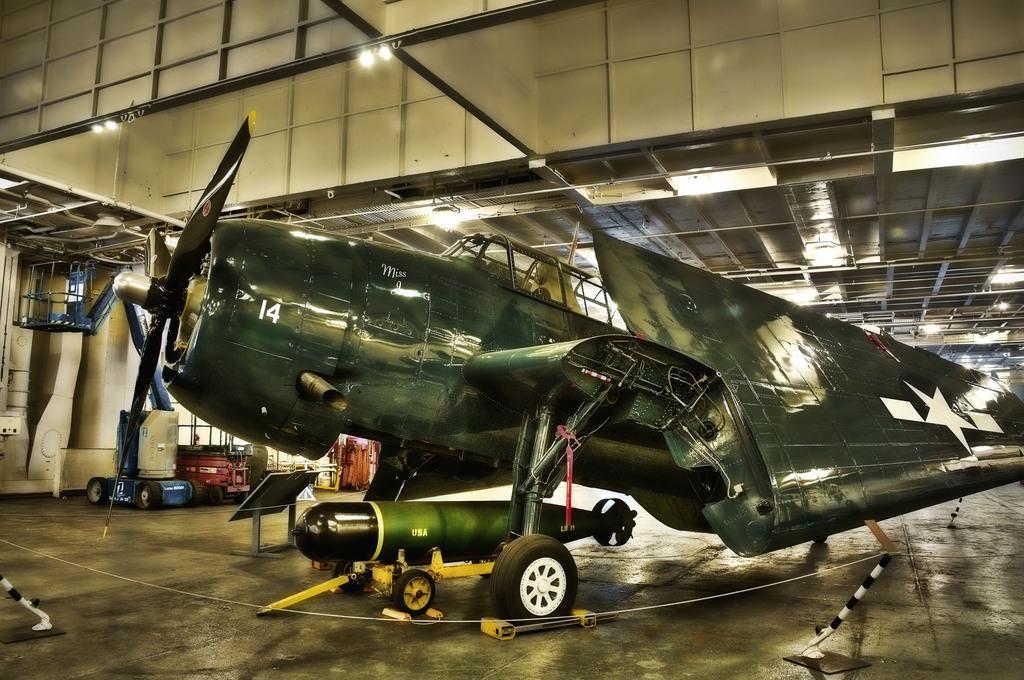Can you describe this image briefly? This image consists of a plane in green color. At the bottom, there is a missile. This image is clicked in a hanger. 